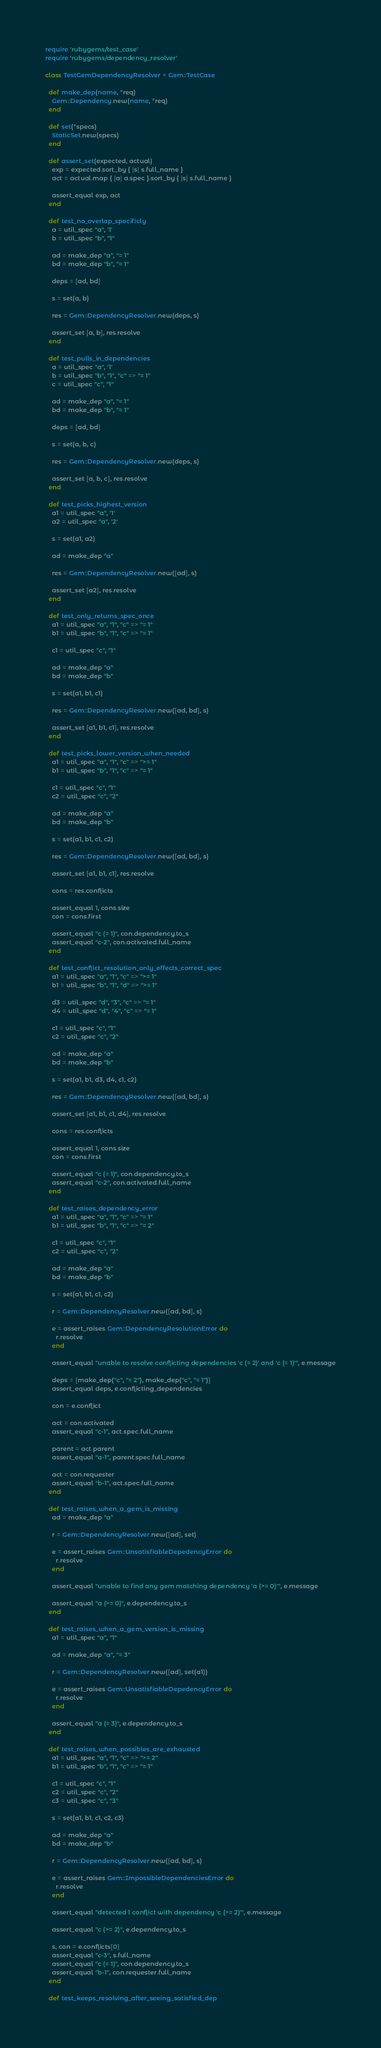Convert code to text. <code><loc_0><loc_0><loc_500><loc_500><_Ruby_>require 'rubygems/test_case'
require 'rubygems/dependency_resolver'

class TestGemDependencyResolver < Gem::TestCase

  def make_dep(name, *req)
    Gem::Dependency.new(name, *req)
  end

  def set(*specs)
    StaticSet.new(specs)
  end

  def assert_set(expected, actual)
    exp = expected.sort_by { |s| s.full_name }
    act = actual.map { |a| a.spec }.sort_by { |s| s.full_name }

    assert_equal exp, act
  end

  def test_no_overlap_specificly
    a = util_spec "a", '1'
    b = util_spec "b", "1"

    ad = make_dep "a", "= 1"
    bd = make_dep "b", "= 1"

    deps = [ad, bd]

    s = set(a, b)

    res = Gem::DependencyResolver.new(deps, s)

    assert_set [a, b], res.resolve
  end

  def test_pulls_in_dependencies
    a = util_spec "a", '1'
    b = util_spec "b", "1", "c" => "= 1"
    c = util_spec "c", "1"

    ad = make_dep "a", "= 1"
    bd = make_dep "b", "= 1"

    deps = [ad, bd]

    s = set(a, b, c)

    res = Gem::DependencyResolver.new(deps, s)

    assert_set [a, b, c], res.resolve
  end

  def test_picks_highest_version
    a1 = util_spec "a", '1'
    a2 = util_spec "a", '2'

    s = set(a1, a2)

    ad = make_dep "a"

    res = Gem::DependencyResolver.new([ad], s)

    assert_set [a2], res.resolve
  end

  def test_only_returns_spec_once
    a1 = util_spec "a", "1", "c" => "= 1"
    b1 = util_spec "b", "1", "c" => "= 1"

    c1 = util_spec "c", "1"

    ad = make_dep "a"
    bd = make_dep "b"

    s = set(a1, b1, c1)

    res = Gem::DependencyResolver.new([ad, bd], s)

    assert_set [a1, b1, c1], res.resolve
  end

  def test_picks_lower_version_when_needed
    a1 = util_spec "a", "1", "c" => ">= 1"
    b1 = util_spec "b", "1", "c" => "= 1"

    c1 = util_spec "c", "1"
    c2 = util_spec "c", "2"

    ad = make_dep "a"
    bd = make_dep "b"

    s = set(a1, b1, c1, c2)

    res = Gem::DependencyResolver.new([ad, bd], s)

    assert_set [a1, b1, c1], res.resolve

    cons = res.conflicts

    assert_equal 1, cons.size
    con = cons.first

    assert_equal "c (= 1)", con.dependency.to_s
    assert_equal "c-2", con.activated.full_name
  end

  def test_conflict_resolution_only_effects_correct_spec
    a1 = util_spec "a", "1", "c" => ">= 1"
    b1 = util_spec "b", "1", "d" => ">= 1"

    d3 = util_spec "d", "3", "c" => "= 1"
    d4 = util_spec "d", "4", "c" => "= 1"

    c1 = util_spec "c", "1"
    c2 = util_spec "c", "2"

    ad = make_dep "a"
    bd = make_dep "b"

    s = set(a1, b1, d3, d4, c1, c2)

    res = Gem::DependencyResolver.new([ad, bd], s)

    assert_set [a1, b1, c1, d4], res.resolve

    cons = res.conflicts

    assert_equal 1, cons.size
    con = cons.first

    assert_equal "c (= 1)", con.dependency.to_s
    assert_equal "c-2", con.activated.full_name
  end

  def test_raises_dependency_error
    a1 = util_spec "a", "1", "c" => "= 1"
    b1 = util_spec "b", "1", "c" => "= 2"

    c1 = util_spec "c", "1"
    c2 = util_spec "c", "2"

    ad = make_dep "a"
    bd = make_dep "b"

    s = set(a1, b1, c1, c2)

    r = Gem::DependencyResolver.new([ad, bd], s)

    e = assert_raises Gem::DependencyResolutionError do
      r.resolve
    end

    assert_equal "unable to resolve conflicting dependencies 'c (= 2)' and 'c (= 1)'", e.message

    deps = [make_dep("c", "= 2"), make_dep("c", "= 1")]
    assert_equal deps, e.conflicting_dependencies

    con = e.conflict

    act = con.activated
    assert_equal "c-1", act.spec.full_name

    parent = act.parent
    assert_equal "a-1", parent.spec.full_name

    act = con.requester
    assert_equal "b-1", act.spec.full_name
  end

  def test_raises_when_a_gem_is_missing
    ad = make_dep "a"

    r = Gem::DependencyResolver.new([ad], set)

    e = assert_raises Gem::UnsatisfiableDepedencyError do
      r.resolve
    end

    assert_equal "unable to find any gem matching dependency 'a (>= 0)'", e.message

    assert_equal "a (>= 0)", e.dependency.to_s
  end

  def test_raises_when_a_gem_version_is_missing
    a1 = util_spec "a", "1"

    ad = make_dep "a", "= 3"

    r = Gem::DependencyResolver.new([ad], set(a1))

    e = assert_raises Gem::UnsatisfiableDepedencyError do
      r.resolve
    end

    assert_equal "a (= 3)", e.dependency.to_s
  end

  def test_raises_when_possibles_are_exhausted
    a1 = util_spec "a", "1", "c" => ">= 2"
    b1 = util_spec "b", "1", "c" => "= 1"

    c1 = util_spec "c", "1"
    c2 = util_spec "c", "2"
    c3 = util_spec "c", "3"

    s = set(a1, b1, c1, c2, c3)

    ad = make_dep "a"
    bd = make_dep "b"

    r = Gem::DependencyResolver.new([ad, bd], s)

    e = assert_raises Gem::ImpossibleDependenciesError do
      r.resolve
    end

    assert_equal "detected 1 conflict with dependency 'c (>= 2)'", e.message

    assert_equal "c (>= 2)", e.dependency.to_s

    s, con = e.conflicts[0]
    assert_equal "c-3", s.full_name
    assert_equal "c (= 1)", con.dependency.to_s
    assert_equal "b-1", con.requester.full_name
  end

  def test_keeps_resolving_after_seeing_satisfied_dep</code> 